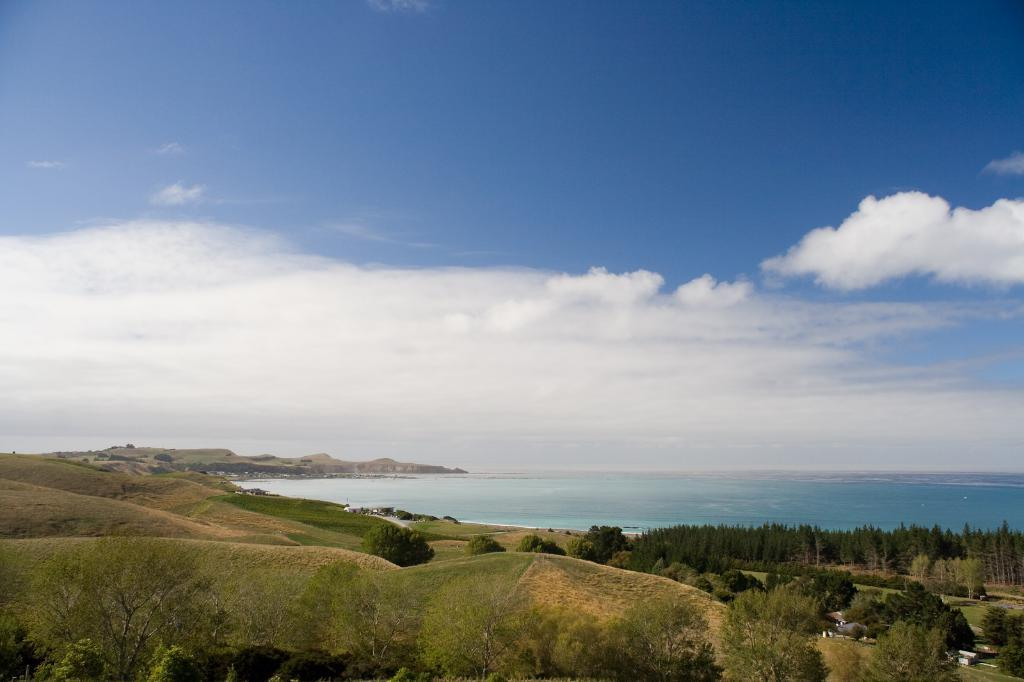What is visible at the top of the image? The sky is visible at the top of the image. What body of water is in the middle of the image? There is an ocean in the middle of the image. What type of vegetation is present around the ocean? Trees and bushes are visible around the ocean. What type of landform is present in the image? There is a hill in the image. Can you tell me how many pigs are swimming in the ocean in the image? There are no pigs present in the image; it features an ocean with trees and bushes around it. What type of needle can be seen sewing a sneeze in the image? There is no needle or sneeze present in the image. 